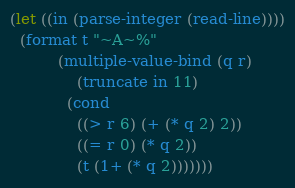<code> <loc_0><loc_0><loc_500><loc_500><_Lisp_>(let ((in (parse-integer (read-line))))
  (format t "~A~%"
          (multiple-value-bind (q r)
              (truncate in 11)
            (cond
              ((> r 6) (+ (* q 2) 2))
              ((= r 0) (* q 2))
              (t (1+ (* q 2)))))))</code> 